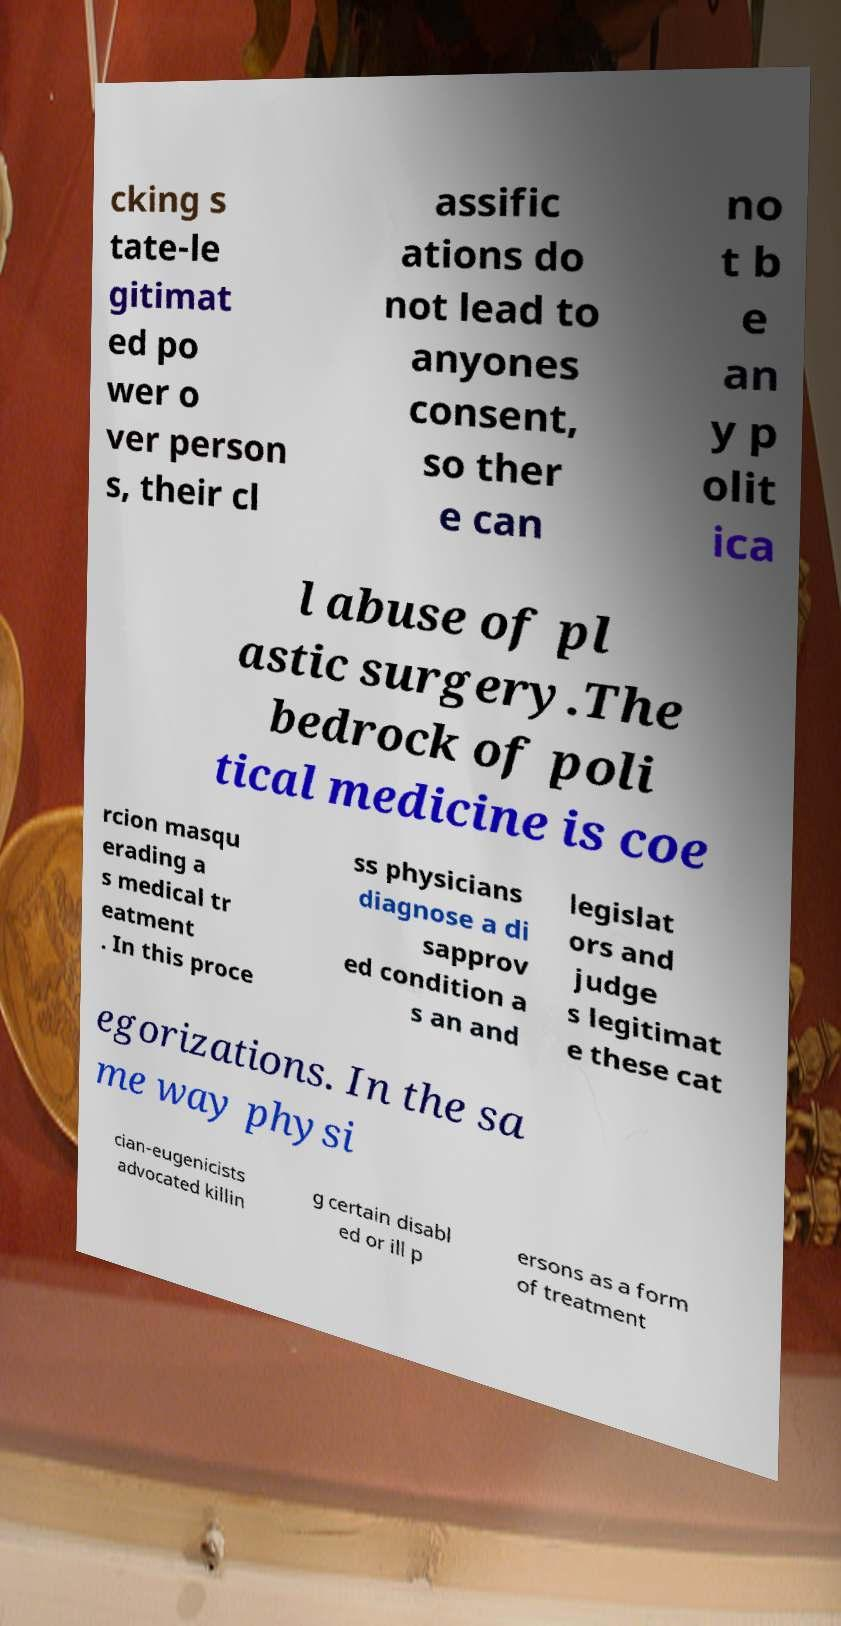What messages or text are displayed in this image? I need them in a readable, typed format. cking s tate-le gitimat ed po wer o ver person s, their cl assific ations do not lead to anyones consent, so ther e can no t b e an y p olit ica l abuse of pl astic surgery.The bedrock of poli tical medicine is coe rcion masqu erading a s medical tr eatment . In this proce ss physicians diagnose a di sapprov ed condition a s an and legislat ors and judge s legitimat e these cat egorizations. In the sa me way physi cian-eugenicists advocated killin g certain disabl ed or ill p ersons as a form of treatment 